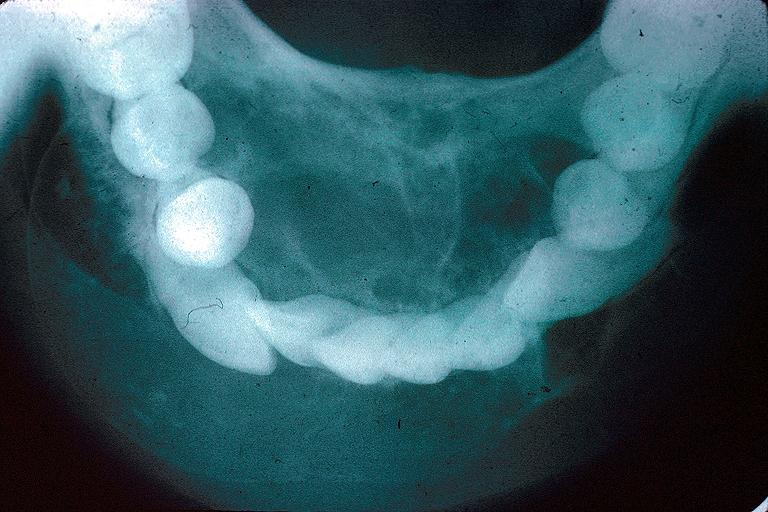s oral present?
Answer the question using a single word or phrase. Yes 